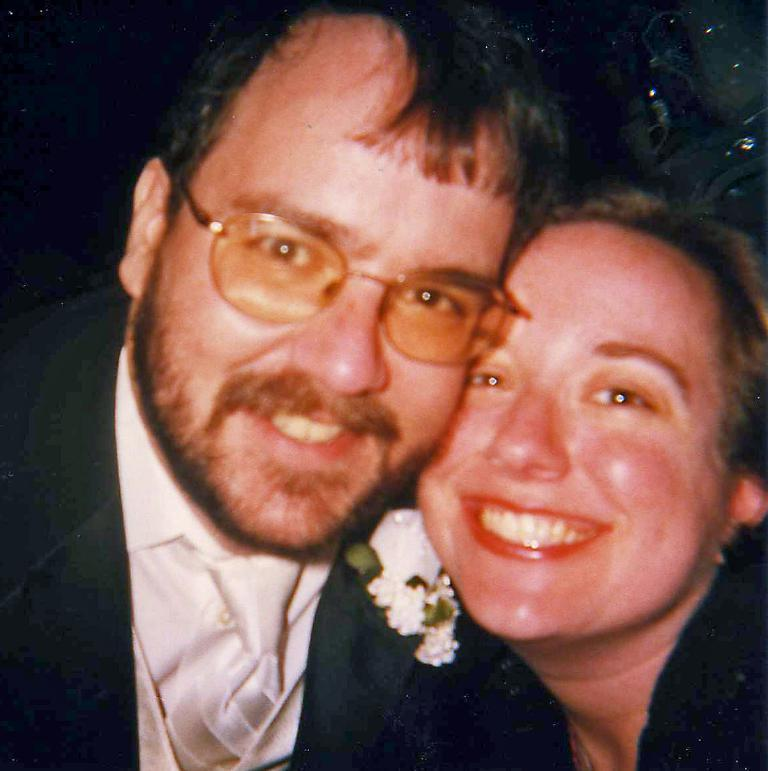Who are the people in the image? There is a woman and a man in the image. What is the man wearing? The man is wearing spectacles. What expressions do the people in the image have? Both the woman and the man are smiling. What can be said about the lighting in the image? The background of the image is dark. What is the process of the woman teaching the class in the image? There is no class or teaching activity depicted in the image; it simply shows a woman and a man smiling. How many minutes does it take for the man to complete his task in the image? There is no task being performed by the man in the image, so it is not possible to determine how many minutes it would take to complete. 